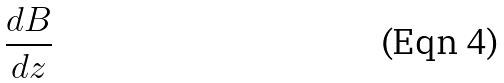<formula> <loc_0><loc_0><loc_500><loc_500>\frac { d B } { d z }</formula> 